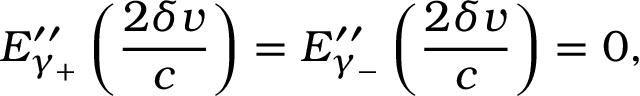<formula> <loc_0><loc_0><loc_500><loc_500>E _ { \gamma _ { + } } ^ { \prime \prime } \left ( \frac { 2 \delta v } { c } \right ) = E _ { \gamma _ { - } } ^ { \prime \prime } \left ( \frac { 2 \delta v } { c } \right ) = 0 ,</formula> 